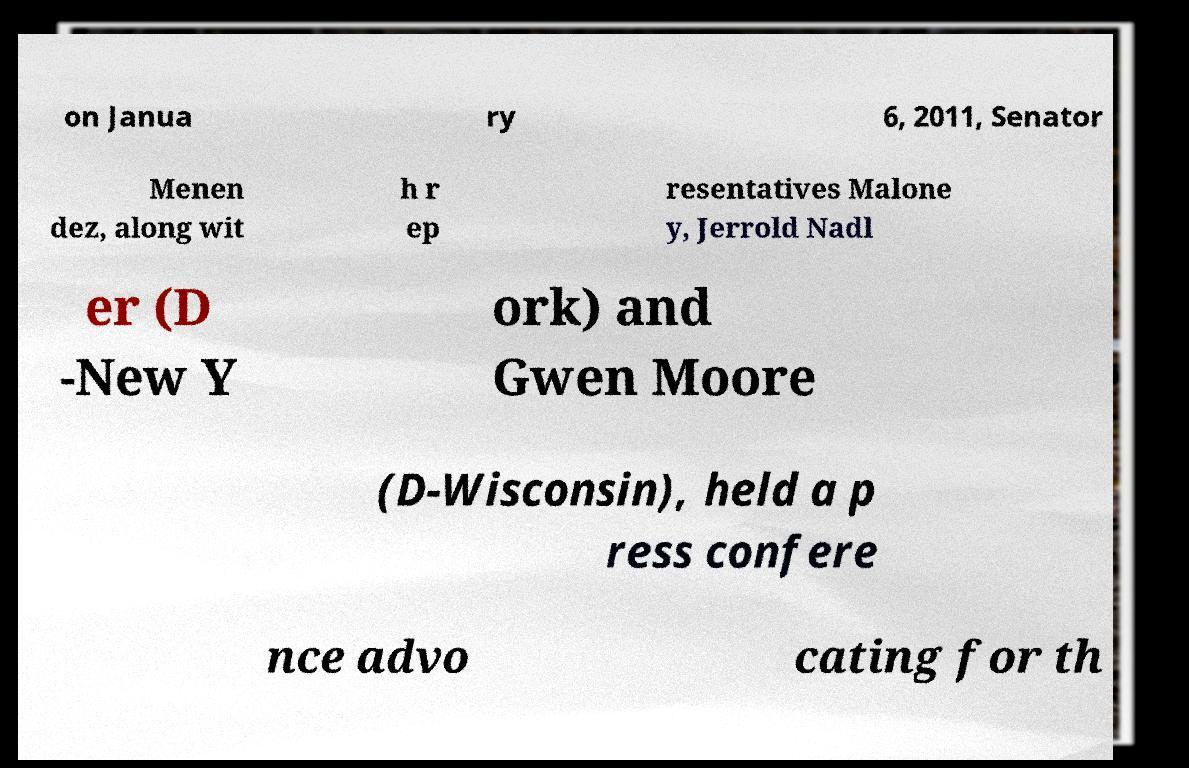For documentation purposes, I need the text within this image transcribed. Could you provide that? on Janua ry 6, 2011, Senator Menen dez, along wit h r ep resentatives Malone y, Jerrold Nadl er (D -New Y ork) and Gwen Moore (D-Wisconsin), held a p ress confere nce advo cating for th 